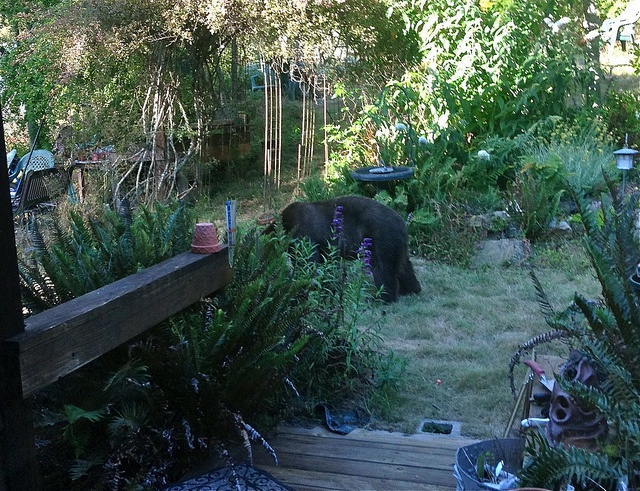Describe the objects in this image and their specific colors. I can see potted plant in darkgreen, black, and teal tones, potted plant in darkgreen and teal tones, potted plant in darkgreen, black, blue, navy, and gray tones, bear in darkgreen, black, navy, purple, and teal tones, and chair in darkgreen, black, gray, and purple tones in this image. 